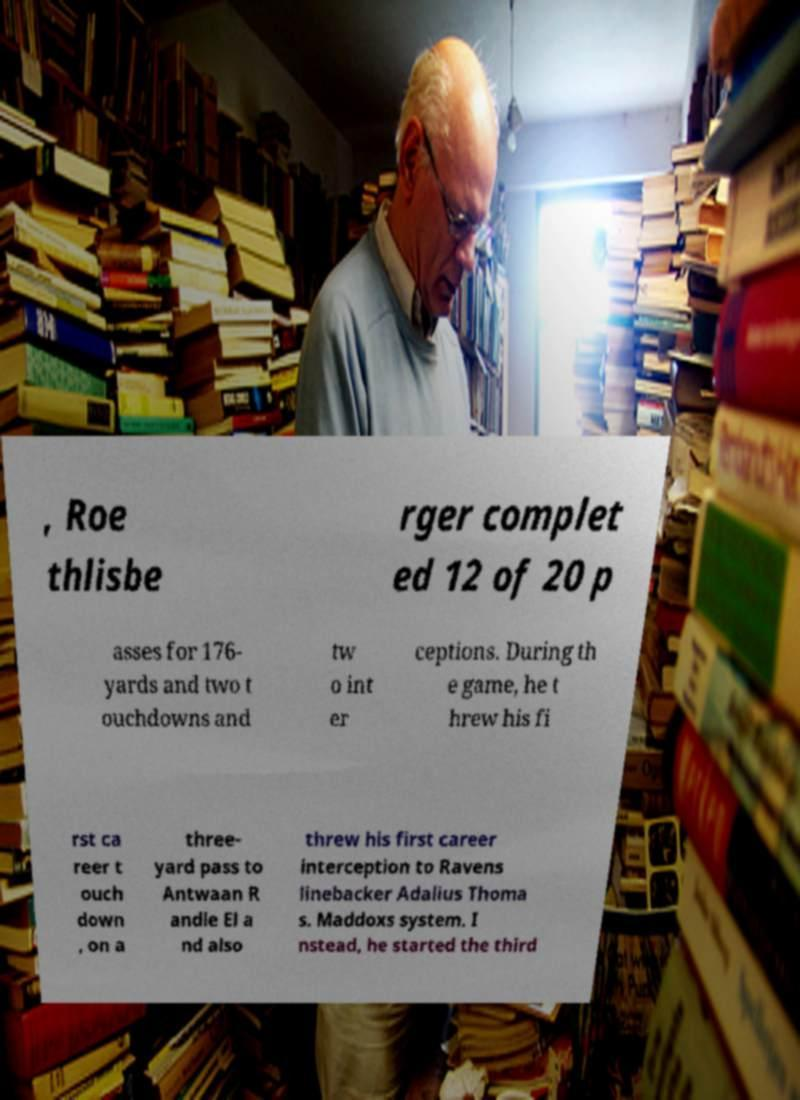For documentation purposes, I need the text within this image transcribed. Could you provide that? , Roe thlisbe rger complet ed 12 of 20 p asses for 176- yards and two t ouchdowns and tw o int er ceptions. During th e game, he t hrew his fi rst ca reer t ouch down , on a three- yard pass to Antwaan R andle El a nd also threw his first career interception to Ravens linebacker Adalius Thoma s. Maddoxs system. I nstead, he started the third 